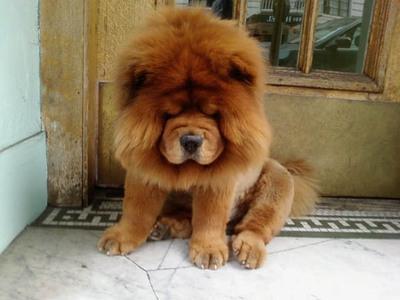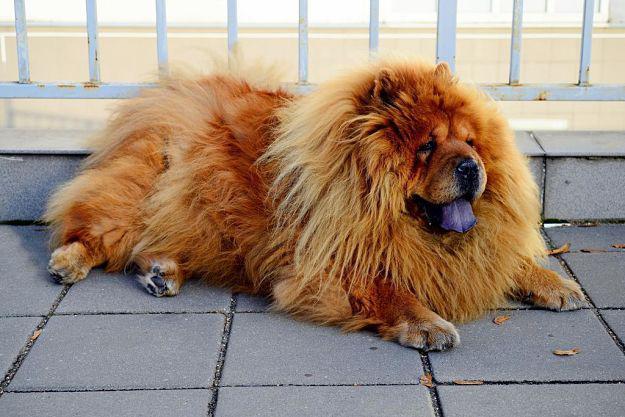The first image is the image on the left, the second image is the image on the right. Assess this claim about the two images: "Two dogs have their mouths open and tongues sticking out.". Correct or not? Answer yes or no. No. The first image is the image on the left, the second image is the image on the right. For the images displayed, is the sentence "The dogs in both images are sticking their tongues out." factually correct? Answer yes or no. No. 